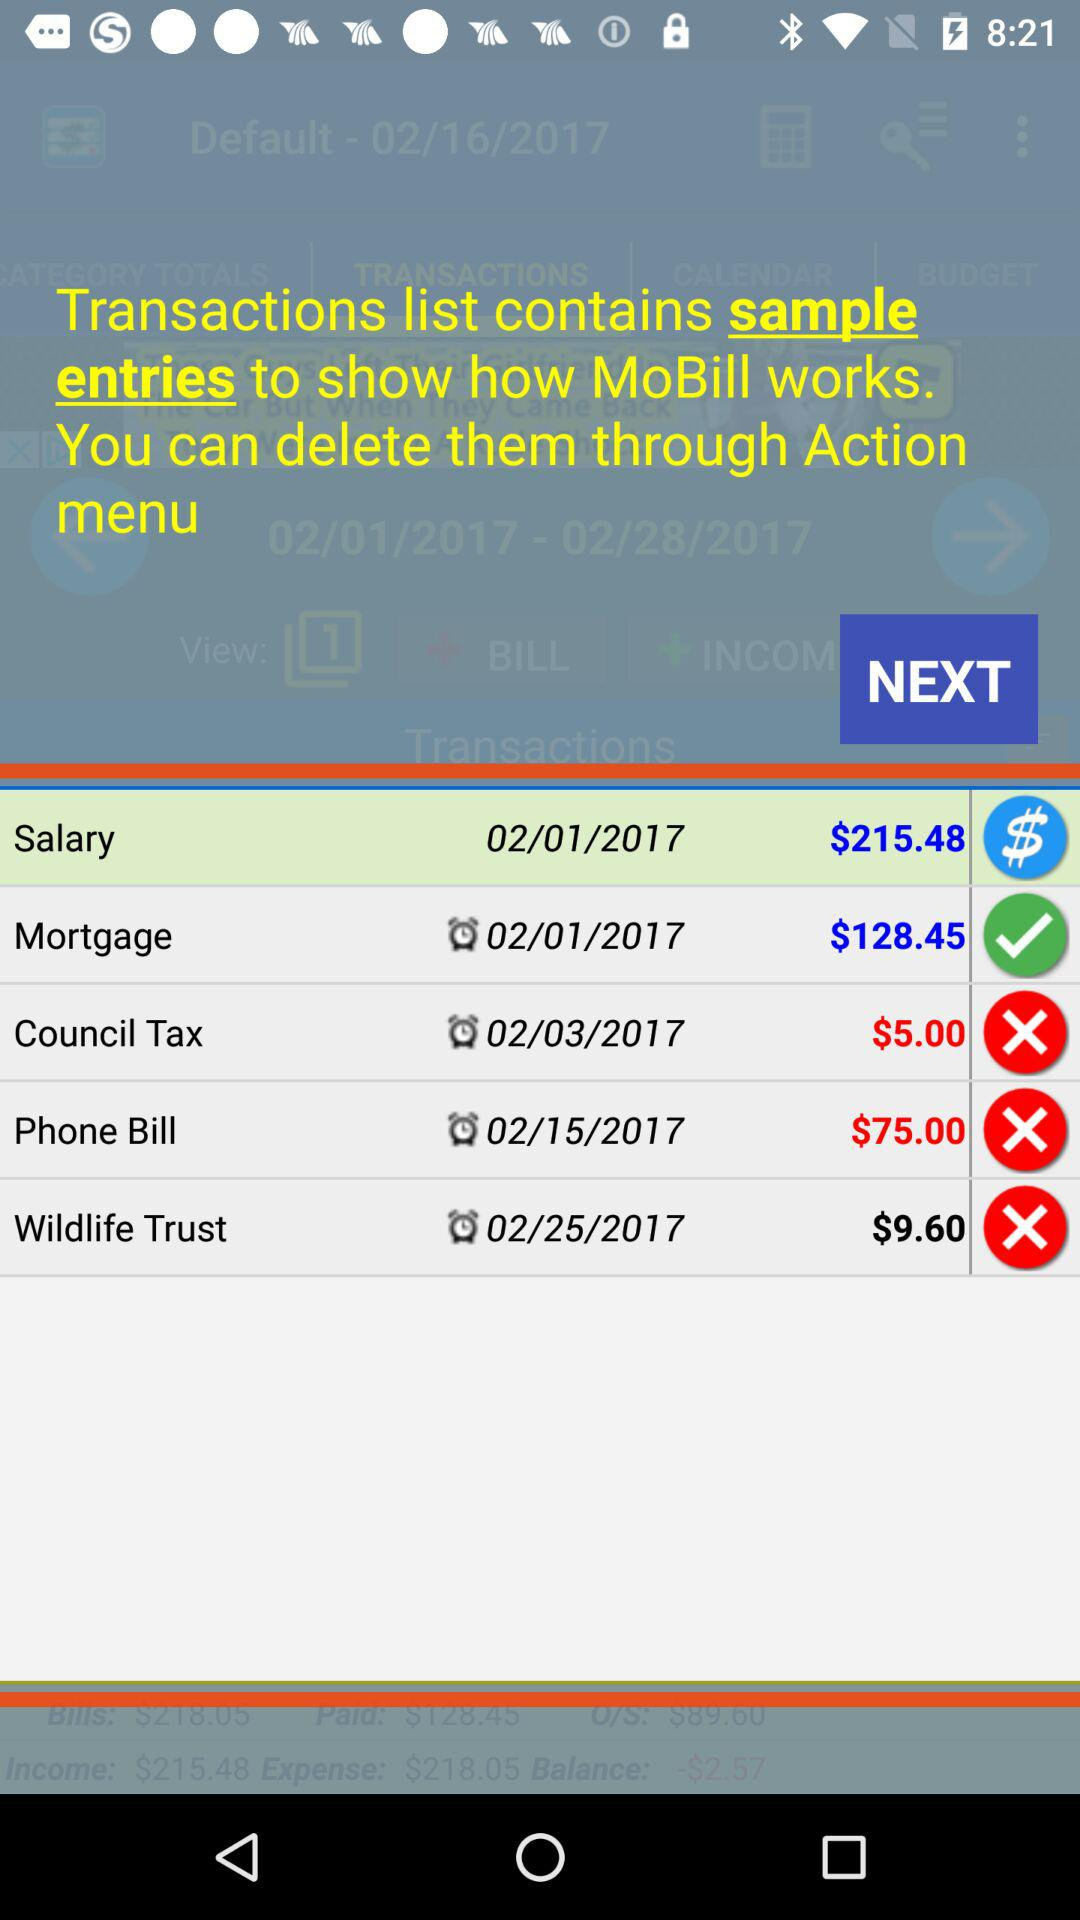On 02/25/2017, which option was updated?
When the provided information is insufficient, respond with <no answer>. <no answer> 